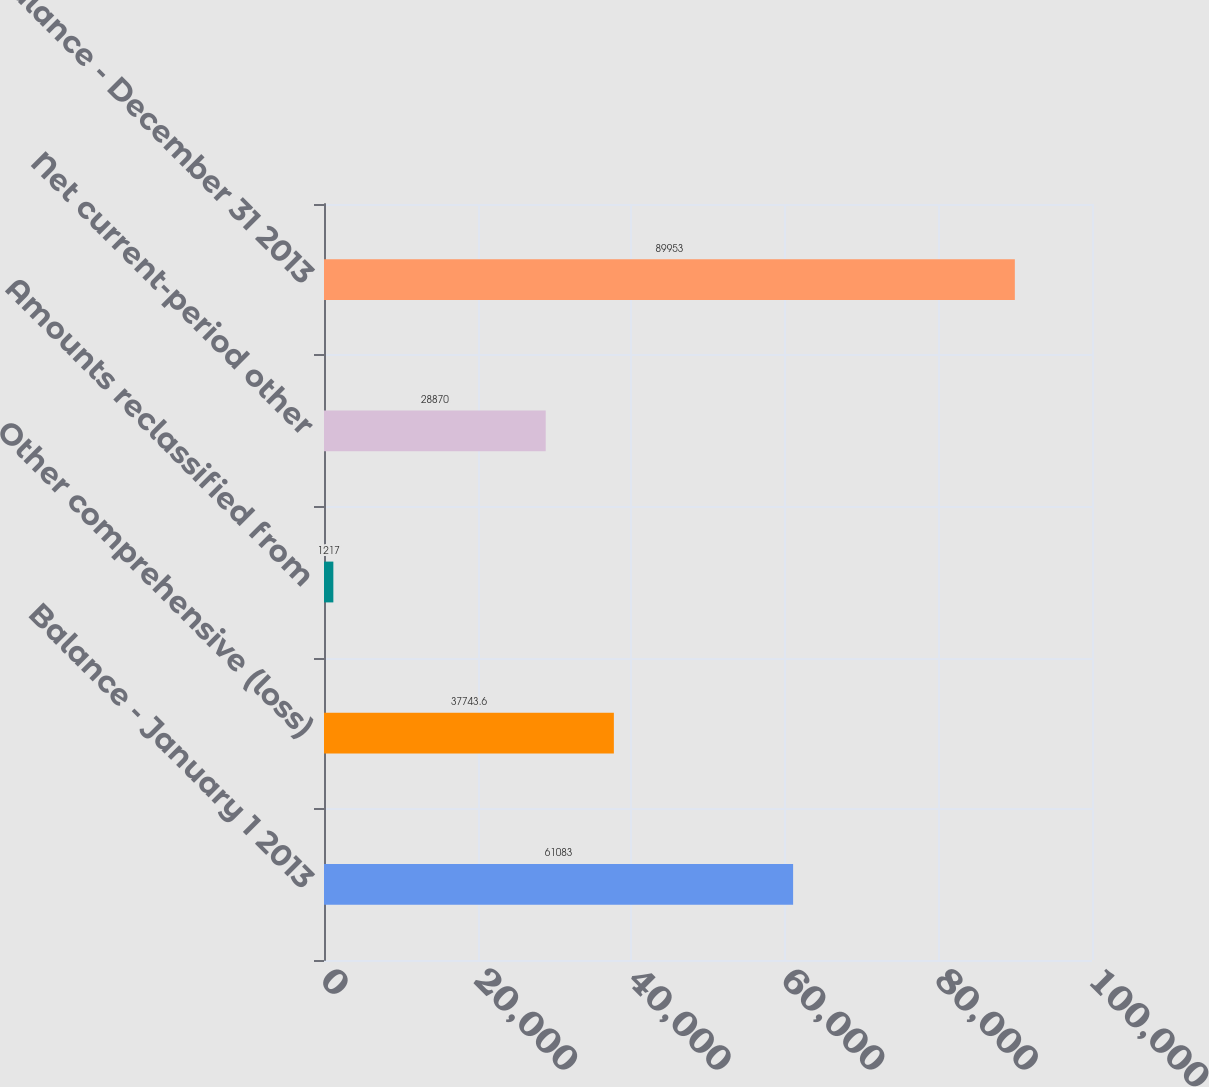Convert chart to OTSL. <chart><loc_0><loc_0><loc_500><loc_500><bar_chart><fcel>Balance - January 1 2013<fcel>Other comprehensive (loss)<fcel>Amounts reclassified from<fcel>Net current-period other<fcel>Balance - December 31 2013<nl><fcel>61083<fcel>37743.6<fcel>1217<fcel>28870<fcel>89953<nl></chart> 